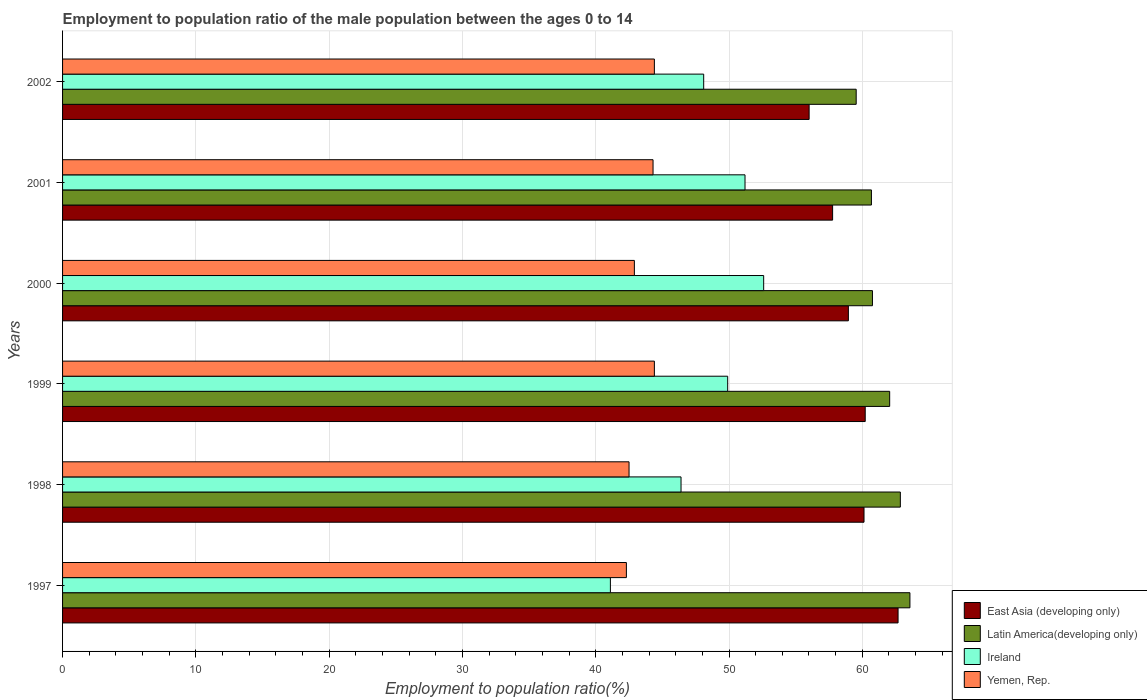How many different coloured bars are there?
Provide a succinct answer. 4. How many groups of bars are there?
Offer a very short reply. 6. Are the number of bars per tick equal to the number of legend labels?
Give a very brief answer. Yes. How many bars are there on the 6th tick from the bottom?
Keep it short and to the point. 4. What is the label of the 6th group of bars from the top?
Offer a very short reply. 1997. What is the employment to population ratio in Yemen, Rep. in 2002?
Offer a very short reply. 44.4. Across all years, what is the maximum employment to population ratio in East Asia (developing only)?
Keep it short and to the point. 62.68. Across all years, what is the minimum employment to population ratio in Yemen, Rep.?
Your answer should be very brief. 42.3. In which year was the employment to population ratio in East Asia (developing only) minimum?
Give a very brief answer. 2002. What is the total employment to population ratio in East Asia (developing only) in the graph?
Your answer should be compact. 355.77. What is the difference between the employment to population ratio in Ireland in 1998 and that in 2002?
Provide a succinct answer. -1.7. What is the difference between the employment to population ratio in Yemen, Rep. in 1997 and the employment to population ratio in East Asia (developing only) in 2001?
Your answer should be very brief. -15.47. What is the average employment to population ratio in Ireland per year?
Provide a short and direct response. 48.22. In the year 1997, what is the difference between the employment to population ratio in Latin America(developing only) and employment to population ratio in East Asia (developing only)?
Ensure brevity in your answer.  0.89. What is the ratio of the employment to population ratio in Ireland in 1997 to that in 2002?
Offer a very short reply. 0.85. Is the difference between the employment to population ratio in Latin America(developing only) in 1998 and 2000 greater than the difference between the employment to population ratio in East Asia (developing only) in 1998 and 2000?
Your response must be concise. Yes. What is the difference between the highest and the second highest employment to population ratio in Ireland?
Offer a terse response. 1.4. What is the difference between the highest and the lowest employment to population ratio in Yemen, Rep.?
Your response must be concise. 2.1. In how many years, is the employment to population ratio in Yemen, Rep. greater than the average employment to population ratio in Yemen, Rep. taken over all years?
Provide a succinct answer. 3. Is the sum of the employment to population ratio in Ireland in 2000 and 2001 greater than the maximum employment to population ratio in East Asia (developing only) across all years?
Offer a very short reply. Yes. What does the 1st bar from the top in 1997 represents?
Keep it short and to the point. Yemen, Rep. What does the 1st bar from the bottom in 2002 represents?
Your answer should be very brief. East Asia (developing only). Is it the case that in every year, the sum of the employment to population ratio in Ireland and employment to population ratio in Latin America(developing only) is greater than the employment to population ratio in Yemen, Rep.?
Offer a very short reply. Yes. How many bars are there?
Offer a terse response. 24. Are the values on the major ticks of X-axis written in scientific E-notation?
Give a very brief answer. No. Does the graph contain any zero values?
Offer a terse response. No. Does the graph contain grids?
Your answer should be compact. Yes. Where does the legend appear in the graph?
Your answer should be very brief. Bottom right. What is the title of the graph?
Provide a short and direct response. Employment to population ratio of the male population between the ages 0 to 14. Does "Turks and Caicos Islands" appear as one of the legend labels in the graph?
Give a very brief answer. No. What is the label or title of the X-axis?
Your response must be concise. Employment to population ratio(%). What is the Employment to population ratio(%) of East Asia (developing only) in 1997?
Your answer should be compact. 62.68. What is the Employment to population ratio(%) of Latin America(developing only) in 1997?
Keep it short and to the point. 63.57. What is the Employment to population ratio(%) of Ireland in 1997?
Your answer should be very brief. 41.1. What is the Employment to population ratio(%) of Yemen, Rep. in 1997?
Ensure brevity in your answer.  42.3. What is the Employment to population ratio(%) in East Asia (developing only) in 1998?
Keep it short and to the point. 60.13. What is the Employment to population ratio(%) in Latin America(developing only) in 1998?
Your answer should be compact. 62.85. What is the Employment to population ratio(%) of Ireland in 1998?
Your response must be concise. 46.4. What is the Employment to population ratio(%) of Yemen, Rep. in 1998?
Provide a succinct answer. 42.5. What is the Employment to population ratio(%) of East Asia (developing only) in 1999?
Keep it short and to the point. 60.22. What is the Employment to population ratio(%) of Latin America(developing only) in 1999?
Make the answer very short. 62.05. What is the Employment to population ratio(%) in Ireland in 1999?
Offer a terse response. 49.9. What is the Employment to population ratio(%) of Yemen, Rep. in 1999?
Keep it short and to the point. 44.4. What is the Employment to population ratio(%) of East Asia (developing only) in 2000?
Make the answer very short. 58.95. What is the Employment to population ratio(%) of Latin America(developing only) in 2000?
Offer a terse response. 60.76. What is the Employment to population ratio(%) of Ireland in 2000?
Your answer should be compact. 52.6. What is the Employment to population ratio(%) in Yemen, Rep. in 2000?
Your response must be concise. 42.9. What is the Employment to population ratio(%) of East Asia (developing only) in 2001?
Provide a succinct answer. 57.77. What is the Employment to population ratio(%) in Latin America(developing only) in 2001?
Make the answer very short. 60.68. What is the Employment to population ratio(%) of Ireland in 2001?
Ensure brevity in your answer.  51.2. What is the Employment to population ratio(%) in Yemen, Rep. in 2001?
Ensure brevity in your answer.  44.3. What is the Employment to population ratio(%) of East Asia (developing only) in 2002?
Keep it short and to the point. 56.01. What is the Employment to population ratio(%) in Latin America(developing only) in 2002?
Offer a terse response. 59.54. What is the Employment to population ratio(%) of Ireland in 2002?
Your answer should be very brief. 48.1. What is the Employment to population ratio(%) in Yemen, Rep. in 2002?
Offer a terse response. 44.4. Across all years, what is the maximum Employment to population ratio(%) of East Asia (developing only)?
Make the answer very short. 62.68. Across all years, what is the maximum Employment to population ratio(%) in Latin America(developing only)?
Your answer should be compact. 63.57. Across all years, what is the maximum Employment to population ratio(%) in Ireland?
Keep it short and to the point. 52.6. Across all years, what is the maximum Employment to population ratio(%) in Yemen, Rep.?
Your answer should be compact. 44.4. Across all years, what is the minimum Employment to population ratio(%) in East Asia (developing only)?
Your response must be concise. 56.01. Across all years, what is the minimum Employment to population ratio(%) in Latin America(developing only)?
Your answer should be very brief. 59.54. Across all years, what is the minimum Employment to population ratio(%) in Ireland?
Ensure brevity in your answer.  41.1. Across all years, what is the minimum Employment to population ratio(%) in Yemen, Rep.?
Keep it short and to the point. 42.3. What is the total Employment to population ratio(%) of East Asia (developing only) in the graph?
Ensure brevity in your answer.  355.77. What is the total Employment to population ratio(%) of Latin America(developing only) in the graph?
Keep it short and to the point. 369.46. What is the total Employment to population ratio(%) in Ireland in the graph?
Make the answer very short. 289.3. What is the total Employment to population ratio(%) in Yemen, Rep. in the graph?
Your response must be concise. 260.8. What is the difference between the Employment to population ratio(%) in East Asia (developing only) in 1997 and that in 1998?
Ensure brevity in your answer.  2.56. What is the difference between the Employment to population ratio(%) of Latin America(developing only) in 1997 and that in 1998?
Provide a short and direct response. 0.72. What is the difference between the Employment to population ratio(%) in East Asia (developing only) in 1997 and that in 1999?
Your answer should be very brief. 2.46. What is the difference between the Employment to population ratio(%) of Latin America(developing only) in 1997 and that in 1999?
Your response must be concise. 1.52. What is the difference between the Employment to population ratio(%) of Yemen, Rep. in 1997 and that in 1999?
Give a very brief answer. -2.1. What is the difference between the Employment to population ratio(%) in East Asia (developing only) in 1997 and that in 2000?
Provide a succinct answer. 3.73. What is the difference between the Employment to population ratio(%) of Latin America(developing only) in 1997 and that in 2000?
Keep it short and to the point. 2.81. What is the difference between the Employment to population ratio(%) in Ireland in 1997 and that in 2000?
Ensure brevity in your answer.  -11.5. What is the difference between the Employment to population ratio(%) in Yemen, Rep. in 1997 and that in 2000?
Provide a succinct answer. -0.6. What is the difference between the Employment to population ratio(%) of East Asia (developing only) in 1997 and that in 2001?
Keep it short and to the point. 4.91. What is the difference between the Employment to population ratio(%) of Latin America(developing only) in 1997 and that in 2001?
Your answer should be very brief. 2.89. What is the difference between the Employment to population ratio(%) of Ireland in 1997 and that in 2001?
Your response must be concise. -10.1. What is the difference between the Employment to population ratio(%) of Yemen, Rep. in 1997 and that in 2001?
Your answer should be very brief. -2. What is the difference between the Employment to population ratio(%) of East Asia (developing only) in 1997 and that in 2002?
Offer a terse response. 6.67. What is the difference between the Employment to population ratio(%) in Latin America(developing only) in 1997 and that in 2002?
Offer a very short reply. 4.03. What is the difference between the Employment to population ratio(%) of Ireland in 1997 and that in 2002?
Your answer should be very brief. -7. What is the difference between the Employment to population ratio(%) in East Asia (developing only) in 1998 and that in 1999?
Provide a succinct answer. -0.09. What is the difference between the Employment to population ratio(%) in Latin America(developing only) in 1998 and that in 1999?
Make the answer very short. 0.8. What is the difference between the Employment to population ratio(%) in Ireland in 1998 and that in 1999?
Your answer should be very brief. -3.5. What is the difference between the Employment to population ratio(%) of Yemen, Rep. in 1998 and that in 1999?
Keep it short and to the point. -1.9. What is the difference between the Employment to population ratio(%) in East Asia (developing only) in 1998 and that in 2000?
Your answer should be very brief. 1.17. What is the difference between the Employment to population ratio(%) in Latin America(developing only) in 1998 and that in 2000?
Give a very brief answer. 2.09. What is the difference between the Employment to population ratio(%) of Ireland in 1998 and that in 2000?
Offer a very short reply. -6.2. What is the difference between the Employment to population ratio(%) in Yemen, Rep. in 1998 and that in 2000?
Offer a very short reply. -0.4. What is the difference between the Employment to population ratio(%) of East Asia (developing only) in 1998 and that in 2001?
Your answer should be compact. 2.36. What is the difference between the Employment to population ratio(%) of Latin America(developing only) in 1998 and that in 2001?
Give a very brief answer. 2.17. What is the difference between the Employment to population ratio(%) of Ireland in 1998 and that in 2001?
Offer a very short reply. -4.8. What is the difference between the Employment to population ratio(%) in Yemen, Rep. in 1998 and that in 2001?
Provide a short and direct response. -1.8. What is the difference between the Employment to population ratio(%) of East Asia (developing only) in 1998 and that in 2002?
Offer a very short reply. 4.12. What is the difference between the Employment to population ratio(%) of Latin America(developing only) in 1998 and that in 2002?
Provide a short and direct response. 3.31. What is the difference between the Employment to population ratio(%) of Ireland in 1998 and that in 2002?
Offer a terse response. -1.7. What is the difference between the Employment to population ratio(%) of Yemen, Rep. in 1998 and that in 2002?
Give a very brief answer. -1.9. What is the difference between the Employment to population ratio(%) in East Asia (developing only) in 1999 and that in 2000?
Offer a very short reply. 1.26. What is the difference between the Employment to population ratio(%) in Latin America(developing only) in 1999 and that in 2000?
Your answer should be compact. 1.29. What is the difference between the Employment to population ratio(%) in Ireland in 1999 and that in 2000?
Provide a succinct answer. -2.7. What is the difference between the Employment to population ratio(%) of Yemen, Rep. in 1999 and that in 2000?
Your response must be concise. 1.5. What is the difference between the Employment to population ratio(%) in East Asia (developing only) in 1999 and that in 2001?
Ensure brevity in your answer.  2.45. What is the difference between the Employment to population ratio(%) in Latin America(developing only) in 1999 and that in 2001?
Keep it short and to the point. 1.37. What is the difference between the Employment to population ratio(%) of East Asia (developing only) in 1999 and that in 2002?
Your response must be concise. 4.21. What is the difference between the Employment to population ratio(%) of Latin America(developing only) in 1999 and that in 2002?
Ensure brevity in your answer.  2.51. What is the difference between the Employment to population ratio(%) in Yemen, Rep. in 1999 and that in 2002?
Give a very brief answer. 0. What is the difference between the Employment to population ratio(%) of East Asia (developing only) in 2000 and that in 2001?
Offer a very short reply. 1.18. What is the difference between the Employment to population ratio(%) in Latin America(developing only) in 2000 and that in 2001?
Provide a succinct answer. 0.08. What is the difference between the Employment to population ratio(%) in Ireland in 2000 and that in 2001?
Provide a succinct answer. 1.4. What is the difference between the Employment to population ratio(%) in East Asia (developing only) in 2000 and that in 2002?
Provide a short and direct response. 2.95. What is the difference between the Employment to population ratio(%) in Latin America(developing only) in 2000 and that in 2002?
Ensure brevity in your answer.  1.22. What is the difference between the Employment to population ratio(%) in East Asia (developing only) in 2001 and that in 2002?
Ensure brevity in your answer.  1.76. What is the difference between the Employment to population ratio(%) of Ireland in 2001 and that in 2002?
Your answer should be very brief. 3.1. What is the difference between the Employment to population ratio(%) in East Asia (developing only) in 1997 and the Employment to population ratio(%) in Latin America(developing only) in 1998?
Provide a short and direct response. -0.17. What is the difference between the Employment to population ratio(%) of East Asia (developing only) in 1997 and the Employment to population ratio(%) of Ireland in 1998?
Keep it short and to the point. 16.28. What is the difference between the Employment to population ratio(%) of East Asia (developing only) in 1997 and the Employment to population ratio(%) of Yemen, Rep. in 1998?
Your answer should be very brief. 20.18. What is the difference between the Employment to population ratio(%) in Latin America(developing only) in 1997 and the Employment to population ratio(%) in Ireland in 1998?
Ensure brevity in your answer.  17.17. What is the difference between the Employment to population ratio(%) of Latin America(developing only) in 1997 and the Employment to population ratio(%) of Yemen, Rep. in 1998?
Provide a short and direct response. 21.07. What is the difference between the Employment to population ratio(%) of Ireland in 1997 and the Employment to population ratio(%) of Yemen, Rep. in 1998?
Your answer should be compact. -1.4. What is the difference between the Employment to population ratio(%) in East Asia (developing only) in 1997 and the Employment to population ratio(%) in Latin America(developing only) in 1999?
Provide a succinct answer. 0.63. What is the difference between the Employment to population ratio(%) of East Asia (developing only) in 1997 and the Employment to population ratio(%) of Ireland in 1999?
Your answer should be very brief. 12.78. What is the difference between the Employment to population ratio(%) of East Asia (developing only) in 1997 and the Employment to population ratio(%) of Yemen, Rep. in 1999?
Provide a short and direct response. 18.28. What is the difference between the Employment to population ratio(%) of Latin America(developing only) in 1997 and the Employment to population ratio(%) of Ireland in 1999?
Provide a short and direct response. 13.67. What is the difference between the Employment to population ratio(%) of Latin America(developing only) in 1997 and the Employment to population ratio(%) of Yemen, Rep. in 1999?
Offer a very short reply. 19.17. What is the difference between the Employment to population ratio(%) of East Asia (developing only) in 1997 and the Employment to population ratio(%) of Latin America(developing only) in 2000?
Give a very brief answer. 1.92. What is the difference between the Employment to population ratio(%) in East Asia (developing only) in 1997 and the Employment to population ratio(%) in Ireland in 2000?
Give a very brief answer. 10.08. What is the difference between the Employment to population ratio(%) in East Asia (developing only) in 1997 and the Employment to population ratio(%) in Yemen, Rep. in 2000?
Provide a succinct answer. 19.78. What is the difference between the Employment to population ratio(%) of Latin America(developing only) in 1997 and the Employment to population ratio(%) of Ireland in 2000?
Give a very brief answer. 10.97. What is the difference between the Employment to population ratio(%) in Latin America(developing only) in 1997 and the Employment to population ratio(%) in Yemen, Rep. in 2000?
Your answer should be very brief. 20.67. What is the difference between the Employment to population ratio(%) in Ireland in 1997 and the Employment to population ratio(%) in Yemen, Rep. in 2000?
Offer a very short reply. -1.8. What is the difference between the Employment to population ratio(%) in East Asia (developing only) in 1997 and the Employment to population ratio(%) in Latin America(developing only) in 2001?
Give a very brief answer. 2. What is the difference between the Employment to population ratio(%) of East Asia (developing only) in 1997 and the Employment to population ratio(%) of Ireland in 2001?
Your answer should be very brief. 11.48. What is the difference between the Employment to population ratio(%) of East Asia (developing only) in 1997 and the Employment to population ratio(%) of Yemen, Rep. in 2001?
Provide a short and direct response. 18.38. What is the difference between the Employment to population ratio(%) in Latin America(developing only) in 1997 and the Employment to population ratio(%) in Ireland in 2001?
Your answer should be very brief. 12.37. What is the difference between the Employment to population ratio(%) of Latin America(developing only) in 1997 and the Employment to population ratio(%) of Yemen, Rep. in 2001?
Provide a short and direct response. 19.27. What is the difference between the Employment to population ratio(%) of East Asia (developing only) in 1997 and the Employment to population ratio(%) of Latin America(developing only) in 2002?
Give a very brief answer. 3.14. What is the difference between the Employment to population ratio(%) of East Asia (developing only) in 1997 and the Employment to population ratio(%) of Ireland in 2002?
Give a very brief answer. 14.58. What is the difference between the Employment to population ratio(%) in East Asia (developing only) in 1997 and the Employment to population ratio(%) in Yemen, Rep. in 2002?
Provide a succinct answer. 18.28. What is the difference between the Employment to population ratio(%) in Latin America(developing only) in 1997 and the Employment to population ratio(%) in Ireland in 2002?
Keep it short and to the point. 15.47. What is the difference between the Employment to population ratio(%) in Latin America(developing only) in 1997 and the Employment to population ratio(%) in Yemen, Rep. in 2002?
Provide a succinct answer. 19.17. What is the difference between the Employment to population ratio(%) of East Asia (developing only) in 1998 and the Employment to population ratio(%) of Latin America(developing only) in 1999?
Keep it short and to the point. -1.93. What is the difference between the Employment to population ratio(%) in East Asia (developing only) in 1998 and the Employment to population ratio(%) in Ireland in 1999?
Your answer should be compact. 10.23. What is the difference between the Employment to population ratio(%) in East Asia (developing only) in 1998 and the Employment to population ratio(%) in Yemen, Rep. in 1999?
Make the answer very short. 15.73. What is the difference between the Employment to population ratio(%) in Latin America(developing only) in 1998 and the Employment to population ratio(%) in Ireland in 1999?
Make the answer very short. 12.95. What is the difference between the Employment to population ratio(%) of Latin America(developing only) in 1998 and the Employment to population ratio(%) of Yemen, Rep. in 1999?
Provide a succinct answer. 18.45. What is the difference between the Employment to population ratio(%) in East Asia (developing only) in 1998 and the Employment to population ratio(%) in Latin America(developing only) in 2000?
Your answer should be compact. -0.63. What is the difference between the Employment to population ratio(%) of East Asia (developing only) in 1998 and the Employment to population ratio(%) of Ireland in 2000?
Make the answer very short. 7.53. What is the difference between the Employment to population ratio(%) of East Asia (developing only) in 1998 and the Employment to population ratio(%) of Yemen, Rep. in 2000?
Provide a succinct answer. 17.23. What is the difference between the Employment to population ratio(%) in Latin America(developing only) in 1998 and the Employment to population ratio(%) in Ireland in 2000?
Give a very brief answer. 10.25. What is the difference between the Employment to population ratio(%) in Latin America(developing only) in 1998 and the Employment to population ratio(%) in Yemen, Rep. in 2000?
Offer a very short reply. 19.95. What is the difference between the Employment to population ratio(%) in East Asia (developing only) in 1998 and the Employment to population ratio(%) in Latin America(developing only) in 2001?
Ensure brevity in your answer.  -0.56. What is the difference between the Employment to population ratio(%) of East Asia (developing only) in 1998 and the Employment to population ratio(%) of Ireland in 2001?
Keep it short and to the point. 8.93. What is the difference between the Employment to population ratio(%) in East Asia (developing only) in 1998 and the Employment to population ratio(%) in Yemen, Rep. in 2001?
Ensure brevity in your answer.  15.83. What is the difference between the Employment to population ratio(%) of Latin America(developing only) in 1998 and the Employment to population ratio(%) of Ireland in 2001?
Your answer should be very brief. 11.65. What is the difference between the Employment to population ratio(%) in Latin America(developing only) in 1998 and the Employment to population ratio(%) in Yemen, Rep. in 2001?
Keep it short and to the point. 18.55. What is the difference between the Employment to population ratio(%) in Ireland in 1998 and the Employment to population ratio(%) in Yemen, Rep. in 2001?
Your answer should be compact. 2.1. What is the difference between the Employment to population ratio(%) of East Asia (developing only) in 1998 and the Employment to population ratio(%) of Latin America(developing only) in 2002?
Give a very brief answer. 0.59. What is the difference between the Employment to population ratio(%) of East Asia (developing only) in 1998 and the Employment to population ratio(%) of Ireland in 2002?
Make the answer very short. 12.03. What is the difference between the Employment to population ratio(%) of East Asia (developing only) in 1998 and the Employment to population ratio(%) of Yemen, Rep. in 2002?
Your answer should be very brief. 15.73. What is the difference between the Employment to population ratio(%) of Latin America(developing only) in 1998 and the Employment to population ratio(%) of Ireland in 2002?
Your answer should be compact. 14.75. What is the difference between the Employment to population ratio(%) of Latin America(developing only) in 1998 and the Employment to population ratio(%) of Yemen, Rep. in 2002?
Your answer should be very brief. 18.45. What is the difference between the Employment to population ratio(%) of Ireland in 1998 and the Employment to population ratio(%) of Yemen, Rep. in 2002?
Your answer should be compact. 2. What is the difference between the Employment to population ratio(%) of East Asia (developing only) in 1999 and the Employment to population ratio(%) of Latin America(developing only) in 2000?
Provide a short and direct response. -0.54. What is the difference between the Employment to population ratio(%) in East Asia (developing only) in 1999 and the Employment to population ratio(%) in Ireland in 2000?
Your response must be concise. 7.62. What is the difference between the Employment to population ratio(%) in East Asia (developing only) in 1999 and the Employment to population ratio(%) in Yemen, Rep. in 2000?
Ensure brevity in your answer.  17.32. What is the difference between the Employment to population ratio(%) in Latin America(developing only) in 1999 and the Employment to population ratio(%) in Ireland in 2000?
Ensure brevity in your answer.  9.45. What is the difference between the Employment to population ratio(%) in Latin America(developing only) in 1999 and the Employment to population ratio(%) in Yemen, Rep. in 2000?
Your response must be concise. 19.15. What is the difference between the Employment to population ratio(%) of Ireland in 1999 and the Employment to population ratio(%) of Yemen, Rep. in 2000?
Ensure brevity in your answer.  7. What is the difference between the Employment to population ratio(%) in East Asia (developing only) in 1999 and the Employment to population ratio(%) in Latin America(developing only) in 2001?
Keep it short and to the point. -0.46. What is the difference between the Employment to population ratio(%) in East Asia (developing only) in 1999 and the Employment to population ratio(%) in Ireland in 2001?
Keep it short and to the point. 9.02. What is the difference between the Employment to population ratio(%) of East Asia (developing only) in 1999 and the Employment to population ratio(%) of Yemen, Rep. in 2001?
Make the answer very short. 15.92. What is the difference between the Employment to population ratio(%) in Latin America(developing only) in 1999 and the Employment to population ratio(%) in Ireland in 2001?
Your answer should be very brief. 10.85. What is the difference between the Employment to population ratio(%) in Latin America(developing only) in 1999 and the Employment to population ratio(%) in Yemen, Rep. in 2001?
Make the answer very short. 17.75. What is the difference between the Employment to population ratio(%) in East Asia (developing only) in 1999 and the Employment to population ratio(%) in Latin America(developing only) in 2002?
Your answer should be very brief. 0.68. What is the difference between the Employment to population ratio(%) of East Asia (developing only) in 1999 and the Employment to population ratio(%) of Ireland in 2002?
Provide a short and direct response. 12.12. What is the difference between the Employment to population ratio(%) in East Asia (developing only) in 1999 and the Employment to population ratio(%) in Yemen, Rep. in 2002?
Ensure brevity in your answer.  15.82. What is the difference between the Employment to population ratio(%) in Latin America(developing only) in 1999 and the Employment to population ratio(%) in Ireland in 2002?
Your answer should be compact. 13.95. What is the difference between the Employment to population ratio(%) of Latin America(developing only) in 1999 and the Employment to population ratio(%) of Yemen, Rep. in 2002?
Make the answer very short. 17.65. What is the difference between the Employment to population ratio(%) of East Asia (developing only) in 2000 and the Employment to population ratio(%) of Latin America(developing only) in 2001?
Your response must be concise. -1.73. What is the difference between the Employment to population ratio(%) of East Asia (developing only) in 2000 and the Employment to population ratio(%) of Ireland in 2001?
Your answer should be very brief. 7.75. What is the difference between the Employment to population ratio(%) of East Asia (developing only) in 2000 and the Employment to population ratio(%) of Yemen, Rep. in 2001?
Keep it short and to the point. 14.65. What is the difference between the Employment to population ratio(%) of Latin America(developing only) in 2000 and the Employment to population ratio(%) of Ireland in 2001?
Offer a terse response. 9.56. What is the difference between the Employment to population ratio(%) of Latin America(developing only) in 2000 and the Employment to population ratio(%) of Yemen, Rep. in 2001?
Keep it short and to the point. 16.46. What is the difference between the Employment to population ratio(%) in Ireland in 2000 and the Employment to population ratio(%) in Yemen, Rep. in 2001?
Ensure brevity in your answer.  8.3. What is the difference between the Employment to population ratio(%) of East Asia (developing only) in 2000 and the Employment to population ratio(%) of Latin America(developing only) in 2002?
Offer a terse response. -0.59. What is the difference between the Employment to population ratio(%) of East Asia (developing only) in 2000 and the Employment to population ratio(%) of Ireland in 2002?
Give a very brief answer. 10.85. What is the difference between the Employment to population ratio(%) of East Asia (developing only) in 2000 and the Employment to population ratio(%) of Yemen, Rep. in 2002?
Ensure brevity in your answer.  14.55. What is the difference between the Employment to population ratio(%) in Latin America(developing only) in 2000 and the Employment to population ratio(%) in Ireland in 2002?
Make the answer very short. 12.66. What is the difference between the Employment to population ratio(%) of Latin America(developing only) in 2000 and the Employment to population ratio(%) of Yemen, Rep. in 2002?
Your response must be concise. 16.36. What is the difference between the Employment to population ratio(%) of East Asia (developing only) in 2001 and the Employment to population ratio(%) of Latin America(developing only) in 2002?
Offer a very short reply. -1.77. What is the difference between the Employment to population ratio(%) of East Asia (developing only) in 2001 and the Employment to population ratio(%) of Ireland in 2002?
Offer a very short reply. 9.67. What is the difference between the Employment to population ratio(%) in East Asia (developing only) in 2001 and the Employment to population ratio(%) in Yemen, Rep. in 2002?
Give a very brief answer. 13.37. What is the difference between the Employment to population ratio(%) in Latin America(developing only) in 2001 and the Employment to population ratio(%) in Ireland in 2002?
Ensure brevity in your answer.  12.58. What is the difference between the Employment to population ratio(%) in Latin America(developing only) in 2001 and the Employment to population ratio(%) in Yemen, Rep. in 2002?
Provide a succinct answer. 16.28. What is the average Employment to population ratio(%) of East Asia (developing only) per year?
Offer a terse response. 59.29. What is the average Employment to population ratio(%) of Latin America(developing only) per year?
Your answer should be compact. 61.58. What is the average Employment to population ratio(%) of Ireland per year?
Ensure brevity in your answer.  48.22. What is the average Employment to population ratio(%) in Yemen, Rep. per year?
Offer a terse response. 43.47. In the year 1997, what is the difference between the Employment to population ratio(%) in East Asia (developing only) and Employment to population ratio(%) in Latin America(developing only)?
Offer a terse response. -0.89. In the year 1997, what is the difference between the Employment to population ratio(%) of East Asia (developing only) and Employment to population ratio(%) of Ireland?
Keep it short and to the point. 21.58. In the year 1997, what is the difference between the Employment to population ratio(%) in East Asia (developing only) and Employment to population ratio(%) in Yemen, Rep.?
Provide a succinct answer. 20.38. In the year 1997, what is the difference between the Employment to population ratio(%) of Latin America(developing only) and Employment to population ratio(%) of Ireland?
Provide a short and direct response. 22.47. In the year 1997, what is the difference between the Employment to population ratio(%) in Latin America(developing only) and Employment to population ratio(%) in Yemen, Rep.?
Provide a succinct answer. 21.27. In the year 1997, what is the difference between the Employment to population ratio(%) of Ireland and Employment to population ratio(%) of Yemen, Rep.?
Your response must be concise. -1.2. In the year 1998, what is the difference between the Employment to population ratio(%) in East Asia (developing only) and Employment to population ratio(%) in Latin America(developing only)?
Give a very brief answer. -2.73. In the year 1998, what is the difference between the Employment to population ratio(%) in East Asia (developing only) and Employment to population ratio(%) in Ireland?
Your answer should be very brief. 13.73. In the year 1998, what is the difference between the Employment to population ratio(%) of East Asia (developing only) and Employment to population ratio(%) of Yemen, Rep.?
Your answer should be very brief. 17.63. In the year 1998, what is the difference between the Employment to population ratio(%) of Latin America(developing only) and Employment to population ratio(%) of Ireland?
Your response must be concise. 16.45. In the year 1998, what is the difference between the Employment to population ratio(%) in Latin America(developing only) and Employment to population ratio(%) in Yemen, Rep.?
Offer a very short reply. 20.35. In the year 1998, what is the difference between the Employment to population ratio(%) of Ireland and Employment to population ratio(%) of Yemen, Rep.?
Your answer should be very brief. 3.9. In the year 1999, what is the difference between the Employment to population ratio(%) of East Asia (developing only) and Employment to population ratio(%) of Latin America(developing only)?
Ensure brevity in your answer.  -1.83. In the year 1999, what is the difference between the Employment to population ratio(%) of East Asia (developing only) and Employment to population ratio(%) of Ireland?
Ensure brevity in your answer.  10.32. In the year 1999, what is the difference between the Employment to population ratio(%) of East Asia (developing only) and Employment to population ratio(%) of Yemen, Rep.?
Offer a very short reply. 15.82. In the year 1999, what is the difference between the Employment to population ratio(%) in Latin America(developing only) and Employment to population ratio(%) in Ireland?
Keep it short and to the point. 12.15. In the year 1999, what is the difference between the Employment to population ratio(%) of Latin America(developing only) and Employment to population ratio(%) of Yemen, Rep.?
Your answer should be very brief. 17.65. In the year 1999, what is the difference between the Employment to population ratio(%) in Ireland and Employment to population ratio(%) in Yemen, Rep.?
Offer a very short reply. 5.5. In the year 2000, what is the difference between the Employment to population ratio(%) of East Asia (developing only) and Employment to population ratio(%) of Latin America(developing only)?
Give a very brief answer. -1.81. In the year 2000, what is the difference between the Employment to population ratio(%) in East Asia (developing only) and Employment to population ratio(%) in Ireland?
Offer a very short reply. 6.35. In the year 2000, what is the difference between the Employment to population ratio(%) in East Asia (developing only) and Employment to population ratio(%) in Yemen, Rep.?
Your response must be concise. 16.05. In the year 2000, what is the difference between the Employment to population ratio(%) in Latin America(developing only) and Employment to population ratio(%) in Ireland?
Your response must be concise. 8.16. In the year 2000, what is the difference between the Employment to population ratio(%) of Latin America(developing only) and Employment to population ratio(%) of Yemen, Rep.?
Ensure brevity in your answer.  17.86. In the year 2000, what is the difference between the Employment to population ratio(%) of Ireland and Employment to population ratio(%) of Yemen, Rep.?
Provide a short and direct response. 9.7. In the year 2001, what is the difference between the Employment to population ratio(%) in East Asia (developing only) and Employment to population ratio(%) in Latin America(developing only)?
Provide a succinct answer. -2.91. In the year 2001, what is the difference between the Employment to population ratio(%) in East Asia (developing only) and Employment to population ratio(%) in Ireland?
Keep it short and to the point. 6.57. In the year 2001, what is the difference between the Employment to population ratio(%) in East Asia (developing only) and Employment to population ratio(%) in Yemen, Rep.?
Provide a short and direct response. 13.47. In the year 2001, what is the difference between the Employment to population ratio(%) of Latin America(developing only) and Employment to population ratio(%) of Ireland?
Your answer should be compact. 9.48. In the year 2001, what is the difference between the Employment to population ratio(%) in Latin America(developing only) and Employment to population ratio(%) in Yemen, Rep.?
Keep it short and to the point. 16.38. In the year 2002, what is the difference between the Employment to population ratio(%) in East Asia (developing only) and Employment to population ratio(%) in Latin America(developing only)?
Ensure brevity in your answer.  -3.53. In the year 2002, what is the difference between the Employment to population ratio(%) of East Asia (developing only) and Employment to population ratio(%) of Ireland?
Offer a very short reply. 7.91. In the year 2002, what is the difference between the Employment to population ratio(%) of East Asia (developing only) and Employment to population ratio(%) of Yemen, Rep.?
Your answer should be very brief. 11.61. In the year 2002, what is the difference between the Employment to population ratio(%) in Latin America(developing only) and Employment to population ratio(%) in Ireland?
Your response must be concise. 11.44. In the year 2002, what is the difference between the Employment to population ratio(%) of Latin America(developing only) and Employment to population ratio(%) of Yemen, Rep.?
Ensure brevity in your answer.  15.14. What is the ratio of the Employment to population ratio(%) in East Asia (developing only) in 1997 to that in 1998?
Provide a short and direct response. 1.04. What is the ratio of the Employment to population ratio(%) in Latin America(developing only) in 1997 to that in 1998?
Make the answer very short. 1.01. What is the ratio of the Employment to population ratio(%) in Ireland in 1997 to that in 1998?
Your answer should be compact. 0.89. What is the ratio of the Employment to population ratio(%) in East Asia (developing only) in 1997 to that in 1999?
Keep it short and to the point. 1.04. What is the ratio of the Employment to population ratio(%) in Latin America(developing only) in 1997 to that in 1999?
Provide a succinct answer. 1.02. What is the ratio of the Employment to population ratio(%) of Ireland in 1997 to that in 1999?
Ensure brevity in your answer.  0.82. What is the ratio of the Employment to population ratio(%) of Yemen, Rep. in 1997 to that in 1999?
Your answer should be very brief. 0.95. What is the ratio of the Employment to population ratio(%) in East Asia (developing only) in 1997 to that in 2000?
Offer a very short reply. 1.06. What is the ratio of the Employment to population ratio(%) in Latin America(developing only) in 1997 to that in 2000?
Your response must be concise. 1.05. What is the ratio of the Employment to population ratio(%) of Ireland in 1997 to that in 2000?
Keep it short and to the point. 0.78. What is the ratio of the Employment to population ratio(%) in East Asia (developing only) in 1997 to that in 2001?
Offer a terse response. 1.08. What is the ratio of the Employment to population ratio(%) in Latin America(developing only) in 1997 to that in 2001?
Your answer should be very brief. 1.05. What is the ratio of the Employment to population ratio(%) of Ireland in 1997 to that in 2001?
Your answer should be compact. 0.8. What is the ratio of the Employment to population ratio(%) in Yemen, Rep. in 1997 to that in 2001?
Ensure brevity in your answer.  0.95. What is the ratio of the Employment to population ratio(%) in East Asia (developing only) in 1997 to that in 2002?
Ensure brevity in your answer.  1.12. What is the ratio of the Employment to population ratio(%) in Latin America(developing only) in 1997 to that in 2002?
Keep it short and to the point. 1.07. What is the ratio of the Employment to population ratio(%) in Ireland in 1997 to that in 2002?
Give a very brief answer. 0.85. What is the ratio of the Employment to population ratio(%) of Yemen, Rep. in 1997 to that in 2002?
Offer a terse response. 0.95. What is the ratio of the Employment to population ratio(%) in Latin America(developing only) in 1998 to that in 1999?
Keep it short and to the point. 1.01. What is the ratio of the Employment to population ratio(%) of Ireland in 1998 to that in 1999?
Ensure brevity in your answer.  0.93. What is the ratio of the Employment to population ratio(%) in Yemen, Rep. in 1998 to that in 1999?
Ensure brevity in your answer.  0.96. What is the ratio of the Employment to population ratio(%) of East Asia (developing only) in 1998 to that in 2000?
Make the answer very short. 1.02. What is the ratio of the Employment to population ratio(%) in Latin America(developing only) in 1998 to that in 2000?
Give a very brief answer. 1.03. What is the ratio of the Employment to population ratio(%) of Ireland in 1998 to that in 2000?
Give a very brief answer. 0.88. What is the ratio of the Employment to population ratio(%) of East Asia (developing only) in 1998 to that in 2001?
Ensure brevity in your answer.  1.04. What is the ratio of the Employment to population ratio(%) in Latin America(developing only) in 1998 to that in 2001?
Your answer should be compact. 1.04. What is the ratio of the Employment to population ratio(%) of Ireland in 1998 to that in 2001?
Offer a terse response. 0.91. What is the ratio of the Employment to population ratio(%) of Yemen, Rep. in 1998 to that in 2001?
Provide a succinct answer. 0.96. What is the ratio of the Employment to population ratio(%) of East Asia (developing only) in 1998 to that in 2002?
Offer a very short reply. 1.07. What is the ratio of the Employment to population ratio(%) in Latin America(developing only) in 1998 to that in 2002?
Provide a short and direct response. 1.06. What is the ratio of the Employment to population ratio(%) in Ireland in 1998 to that in 2002?
Ensure brevity in your answer.  0.96. What is the ratio of the Employment to population ratio(%) of Yemen, Rep. in 1998 to that in 2002?
Your response must be concise. 0.96. What is the ratio of the Employment to population ratio(%) in East Asia (developing only) in 1999 to that in 2000?
Your response must be concise. 1.02. What is the ratio of the Employment to population ratio(%) in Latin America(developing only) in 1999 to that in 2000?
Your response must be concise. 1.02. What is the ratio of the Employment to population ratio(%) of Ireland in 1999 to that in 2000?
Offer a very short reply. 0.95. What is the ratio of the Employment to population ratio(%) of Yemen, Rep. in 1999 to that in 2000?
Your response must be concise. 1.03. What is the ratio of the Employment to population ratio(%) in East Asia (developing only) in 1999 to that in 2001?
Provide a succinct answer. 1.04. What is the ratio of the Employment to population ratio(%) of Latin America(developing only) in 1999 to that in 2001?
Ensure brevity in your answer.  1.02. What is the ratio of the Employment to population ratio(%) in Ireland in 1999 to that in 2001?
Ensure brevity in your answer.  0.97. What is the ratio of the Employment to population ratio(%) in Yemen, Rep. in 1999 to that in 2001?
Your answer should be very brief. 1. What is the ratio of the Employment to population ratio(%) of East Asia (developing only) in 1999 to that in 2002?
Keep it short and to the point. 1.08. What is the ratio of the Employment to population ratio(%) of Latin America(developing only) in 1999 to that in 2002?
Provide a short and direct response. 1.04. What is the ratio of the Employment to population ratio(%) in Ireland in 1999 to that in 2002?
Offer a terse response. 1.04. What is the ratio of the Employment to population ratio(%) in East Asia (developing only) in 2000 to that in 2001?
Ensure brevity in your answer.  1.02. What is the ratio of the Employment to population ratio(%) of Ireland in 2000 to that in 2001?
Offer a very short reply. 1.03. What is the ratio of the Employment to population ratio(%) in Yemen, Rep. in 2000 to that in 2001?
Offer a terse response. 0.97. What is the ratio of the Employment to population ratio(%) of East Asia (developing only) in 2000 to that in 2002?
Your response must be concise. 1.05. What is the ratio of the Employment to population ratio(%) of Latin America(developing only) in 2000 to that in 2002?
Offer a very short reply. 1.02. What is the ratio of the Employment to population ratio(%) in Ireland in 2000 to that in 2002?
Ensure brevity in your answer.  1.09. What is the ratio of the Employment to population ratio(%) in Yemen, Rep. in 2000 to that in 2002?
Your response must be concise. 0.97. What is the ratio of the Employment to population ratio(%) in East Asia (developing only) in 2001 to that in 2002?
Your answer should be very brief. 1.03. What is the ratio of the Employment to population ratio(%) of Latin America(developing only) in 2001 to that in 2002?
Keep it short and to the point. 1.02. What is the ratio of the Employment to population ratio(%) of Ireland in 2001 to that in 2002?
Make the answer very short. 1.06. What is the difference between the highest and the second highest Employment to population ratio(%) in East Asia (developing only)?
Provide a succinct answer. 2.46. What is the difference between the highest and the second highest Employment to population ratio(%) in Latin America(developing only)?
Your answer should be very brief. 0.72. What is the difference between the highest and the second highest Employment to population ratio(%) in Yemen, Rep.?
Keep it short and to the point. 0. What is the difference between the highest and the lowest Employment to population ratio(%) of East Asia (developing only)?
Your response must be concise. 6.67. What is the difference between the highest and the lowest Employment to population ratio(%) of Latin America(developing only)?
Your answer should be very brief. 4.03. What is the difference between the highest and the lowest Employment to population ratio(%) in Ireland?
Your response must be concise. 11.5. What is the difference between the highest and the lowest Employment to population ratio(%) of Yemen, Rep.?
Keep it short and to the point. 2.1. 